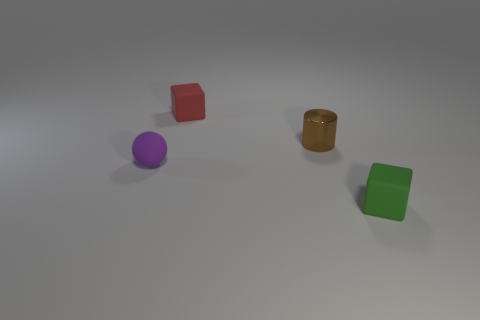Add 3 large yellow spheres. How many objects exist? 7 Subtract 1 cubes. How many cubes are left? 1 Subtract all spheres. How many objects are left? 3 Subtract 1 purple spheres. How many objects are left? 3 Subtract all purple blocks. Subtract all red cylinders. How many blocks are left? 2 Subtract all blue cylinders. How many red cubes are left? 1 Subtract all purple rubber spheres. Subtract all tiny yellow spheres. How many objects are left? 3 Add 4 small purple spheres. How many small purple spheres are left? 5 Add 3 matte things. How many matte things exist? 6 